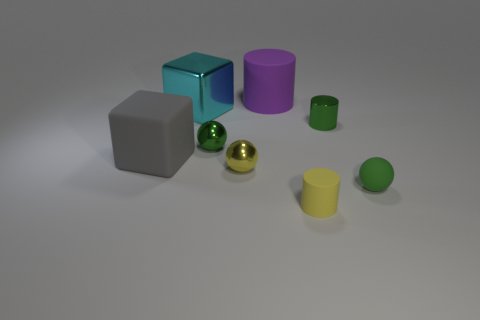Add 1 large purple rubber cubes. How many objects exist? 9 Subtract all large cylinders. How many cylinders are left? 2 Subtract all green spheres. How many spheres are left? 1 Subtract all cyan cubes. How many yellow balls are left? 1 Subtract all yellow cylinders. Subtract all tiny metal objects. How many objects are left? 4 Add 4 small cylinders. How many small cylinders are left? 6 Add 2 blue rubber blocks. How many blue rubber blocks exist? 2 Subtract 0 yellow cubes. How many objects are left? 8 Subtract all spheres. How many objects are left? 5 Subtract 2 cylinders. How many cylinders are left? 1 